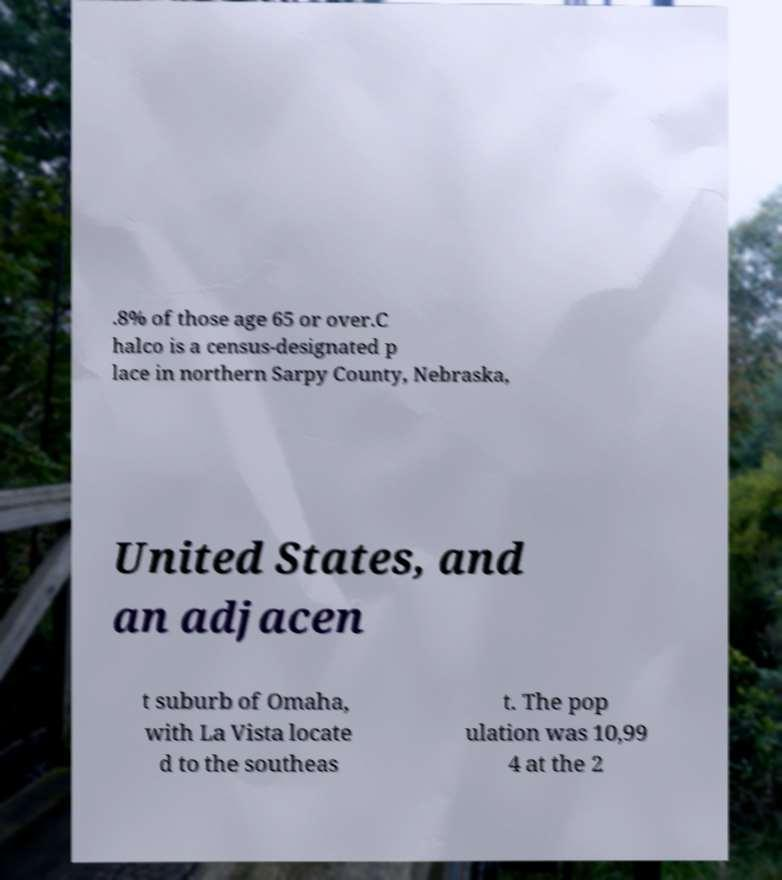I need the written content from this picture converted into text. Can you do that? .8% of those age 65 or over.C halco is a census-designated p lace in northern Sarpy County, Nebraska, United States, and an adjacen t suburb of Omaha, with La Vista locate d to the southeas t. The pop ulation was 10,99 4 at the 2 